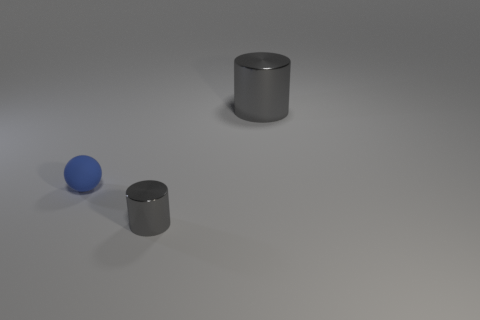Add 2 balls. How many objects exist? 5 Subtract all balls. How many objects are left? 2 Add 3 big gray shiny cylinders. How many big gray shiny cylinders are left? 4 Add 1 tiny objects. How many tiny objects exist? 3 Subtract 0 green cylinders. How many objects are left? 3 Subtract all matte objects. Subtract all large cylinders. How many objects are left? 1 